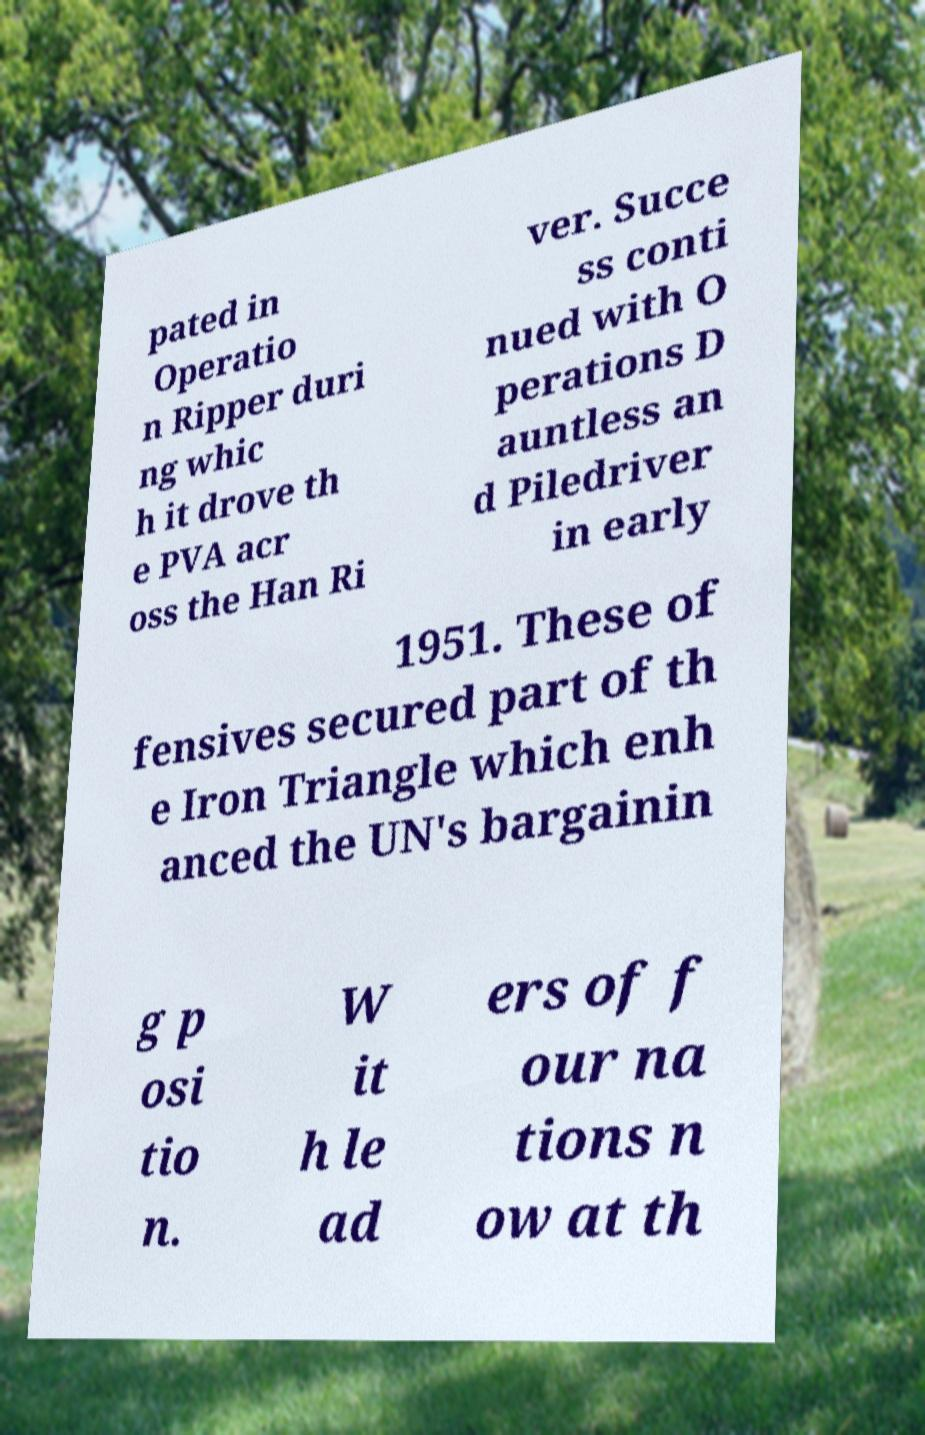There's text embedded in this image that I need extracted. Can you transcribe it verbatim? pated in Operatio n Ripper duri ng whic h it drove th e PVA acr oss the Han Ri ver. Succe ss conti nued with O perations D auntless an d Piledriver in early 1951. These of fensives secured part of th e Iron Triangle which enh anced the UN's bargainin g p osi tio n. W it h le ad ers of f our na tions n ow at th 